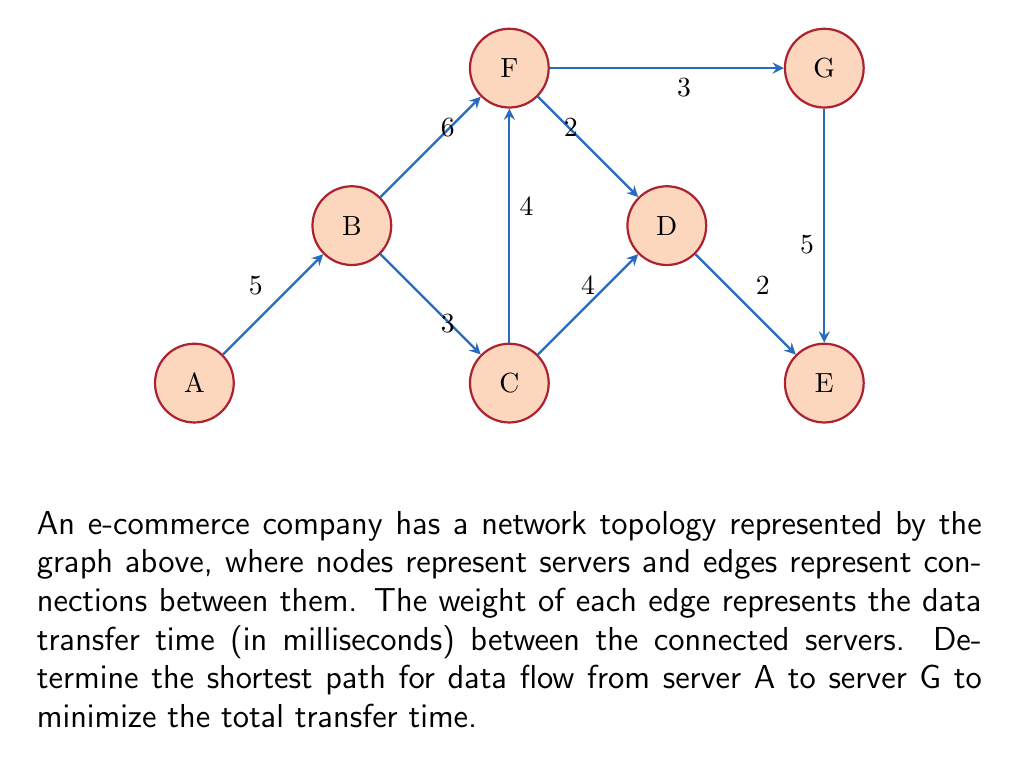Show me your answer to this math problem. To solve this problem, we'll use Dijkstra's algorithm to find the shortest path from server A to server G. Here's a step-by-step explanation:

1) Initialize:
   - Set distance to A as 0, and all other nodes as infinity.
   - Set all nodes as unvisited.
   - Set A as the current node.

2) For the current node, consider all unvisited neighbors and calculate their tentative distances:
   - Distance to B = 0 + 5 = 5
   Update B's distance to 5.

3) Mark A as visited. Set B as the current node (lowest tentative distance among unvisited nodes).

4) From B:
   - Distance to C = 5 + 3 = 8
   - Distance to F = 5 + 6 = 11
   Update C's and F's distances.

5) Mark B as visited. Set C as the current node.

6) From C:
   - Distance to D = 8 + 4 = 12
   - Distance to F = 8 + 4 = 12 (no update, as it's higher than current distance to F)
   Update D's distance.

7) Mark C as visited. Set F as the current node.

8) From F:
   - Distance to D = 11 + 2 = 13 (no update, as it's higher than current distance to D)
   - Distance to G = 11 + 3 = 14
   Update G's distance.

9) Mark F as visited. Set D as the current node.

10) From D:
    - Distance to E = 12 + 2 = 14
    Update E's distance.

11) Mark D as visited. G and E have the same tentative distance. Choose G as it's our target.

12) We've reached G, so we're done. The shortest path is A -> B -> C -> F -> G with a total distance of 14 ms.
Answer: A -> B -> C -> F -> G, 14 ms 